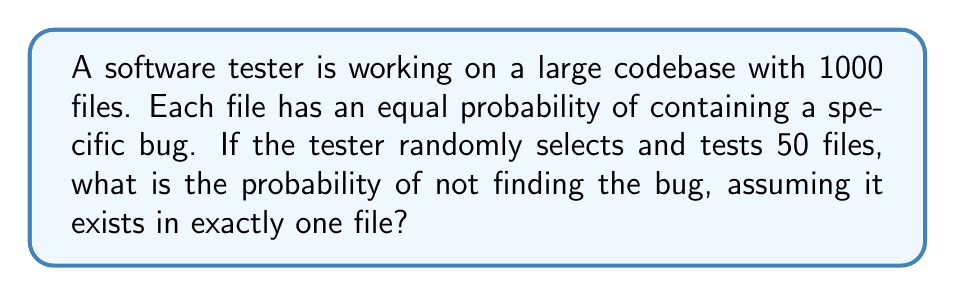What is the answer to this math problem? Let's approach this step-by-step:

1) This is a problem of combinatorics, specifically using the concept of complementary probability.

2) We want to find the probability of not finding the bug, which is easier to calculate than finding it directly.

3) The total number of files is 1000, and the bug is in exactly one file.

4) The tester randomly selects and tests 50 files.

5) To not find the bug, all 50 selected files must not contain the bug.

6) The probability of selecting a file without the bug on the first try is:
   $\frac{999}{1000}$

7) For the second file, given that the first didn't have the bug, the probability is:
   $\frac{998}{999}$

8) This continues for all 50 selections.

9) The probability of not finding the bug in all 50 selections is the product of these individual probabilities:

   $$P(\text{not finding bug}) = \frac{999}{1000} \cdot \frac{998}{999} \cdot \frac{997}{998} \cdot ... \cdot \frac{951}{952} \cdot \frac{950}{951}$$

10) This can be simplified to:

    $$P(\text{not finding bug}) = \frac{950}{1000} = \frac{19}{20} = 0.95$$

11) Therefore, the probability of not finding the bug is 0.95 or 95%.
Answer: 0.95 